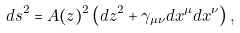<formula> <loc_0><loc_0><loc_500><loc_500>d s ^ { 2 } = A ( z ) ^ { 2 } \left ( d z ^ { 2 } + \gamma _ { \mu \nu } d x ^ { \mu } d x ^ { \nu } \right ) ,</formula> 